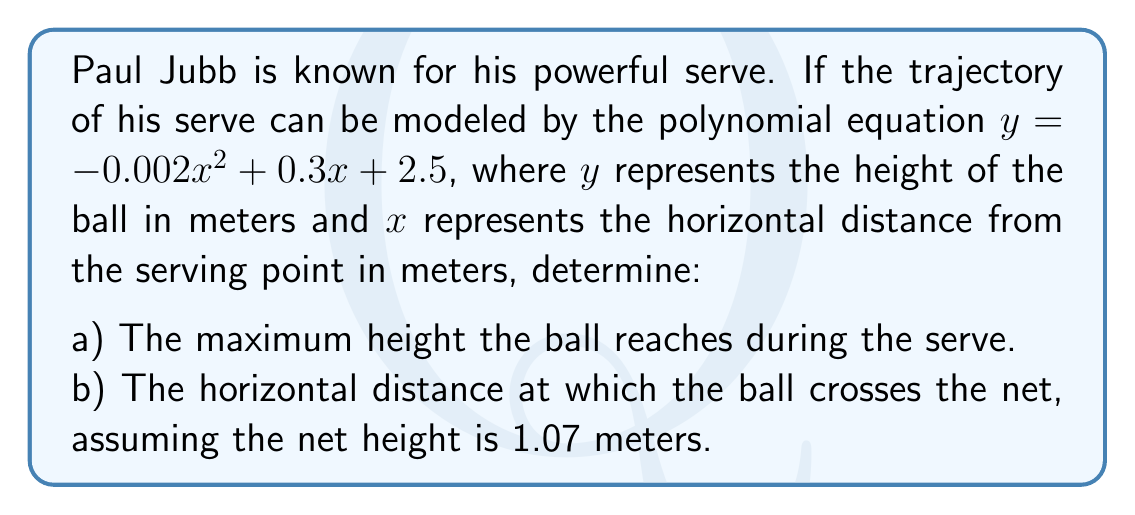Show me your answer to this math problem. Let's approach this problem step by step:

a) To find the maximum height, we need to find the vertex of the parabola. For a quadratic equation in the form $y = ax^2 + bx + c$, the x-coordinate of the vertex is given by $x = -\frac{b}{2a}$.

In this case, $a = -0.002$, $b = 0.3$, and $c = 2.5$.

$x = -\frac{0.3}{2(-0.002)} = 75$ meters

To find the maximum height (y-coordinate of the vertex), we substitute this x-value into the original equation:

$y = -0.002(75)^2 + 0.3(75) + 2.5$
$y = -11.25 + 22.5 + 2.5 = 13.75$ meters

b) To find where the ball crosses the net, we need to solve the equation:

$1.07 = -0.002x^2 + 0.3x + 2.5$

Rearranging the equation:
$0 = -0.002x^2 + 0.3x + 1.43$

This is a quadratic equation. We can solve it using the quadratic formula:
$x = \frac{-b \pm \sqrt{b^2 - 4ac}}{2a}$

Where $a = -0.002$, $b = 0.3$, and $c = 1.43$

$x = \frac{-0.3 \pm \sqrt{0.3^2 - 4(-0.002)(1.43)}}{2(-0.002)}$

$x = \frac{-0.3 \pm \sqrt{0.09 + 0.01144}}{-0.004}$

$x = \frac{-0.3 \pm \sqrt{0.10144}}{-0.004}$

$x = \frac{-0.3 \pm 0.3184}{-0.004}$

This gives us two solutions:
$x_1 = \frac{-0.3 + 0.3184}{-0.004} = 4.6$ meters
$x_2 = \frac{-0.3 - 0.3184}{-0.004} = 154.6$ meters

The ball crosses the net at the first solution, 4.6 meters from the serving point.
Answer: a) The maximum height the ball reaches is 13.75 meters.
b) The ball crosses the net at a horizontal distance of 4.6 meters from the serving point. 